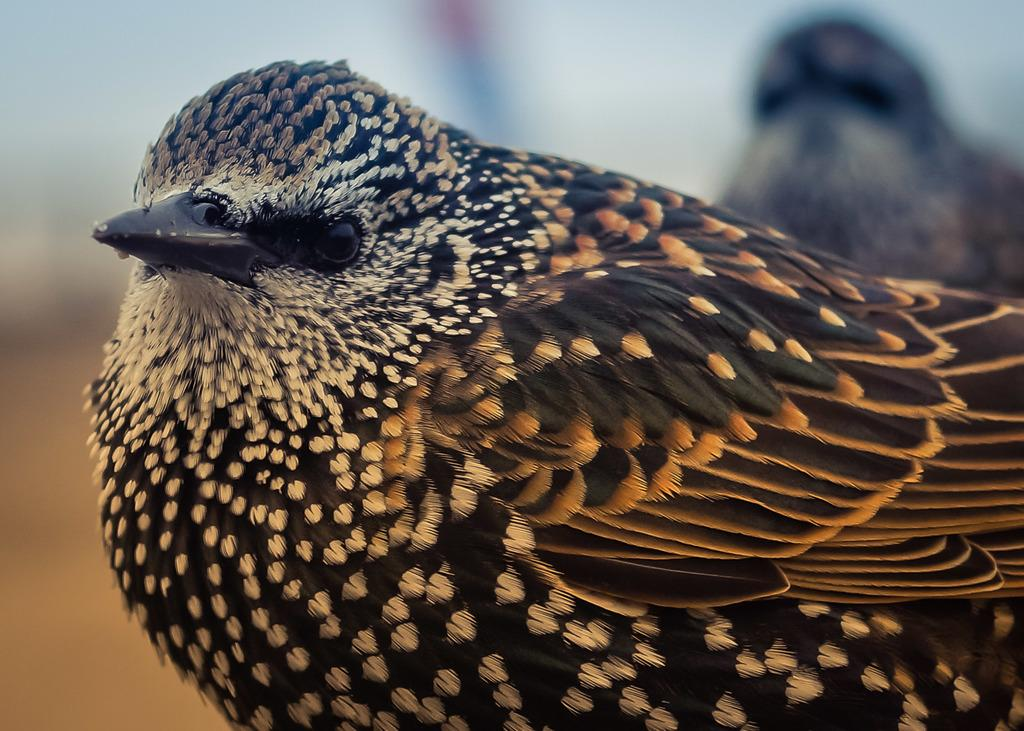What type of animal is present in the image? There is a bird in the image. What color scheme is used for the bird in the image? The bird is in black and white color. What language does the bird speak in the image? Birds do not speak human languages, so there is no language spoken by the bird in the image. 